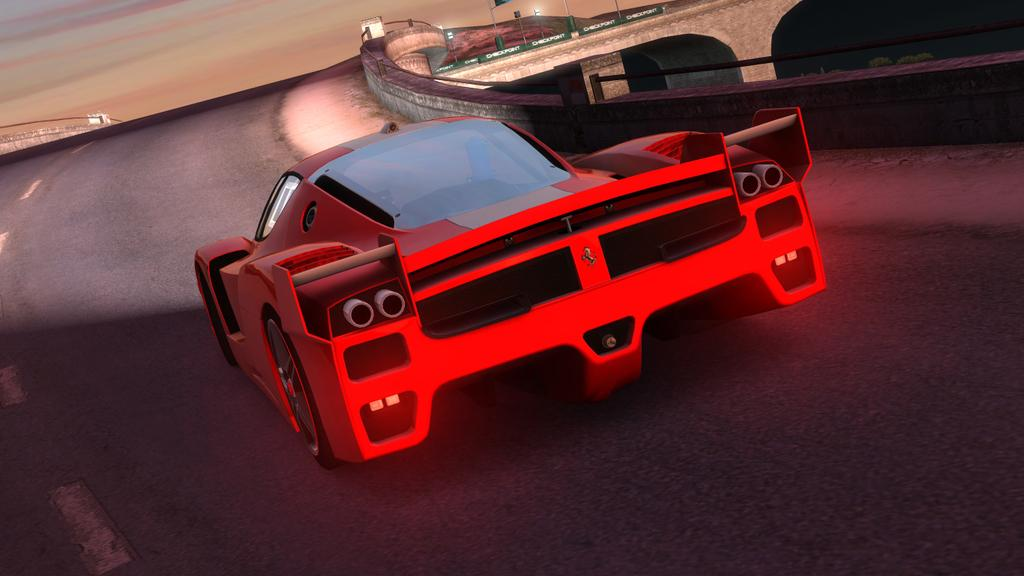What color is the car in the image? The car in the image is red. Where is the car located in the image? The car is on the road in the image. What can be seen in the background of the image? In the background of the image, there are poles, a fence, the sky, and other objects on the ground. What type of animal is being whipped by the driver of the car in the image? There is no animal present in the image, nor is there any indication of a whip or any action involving a whip. 